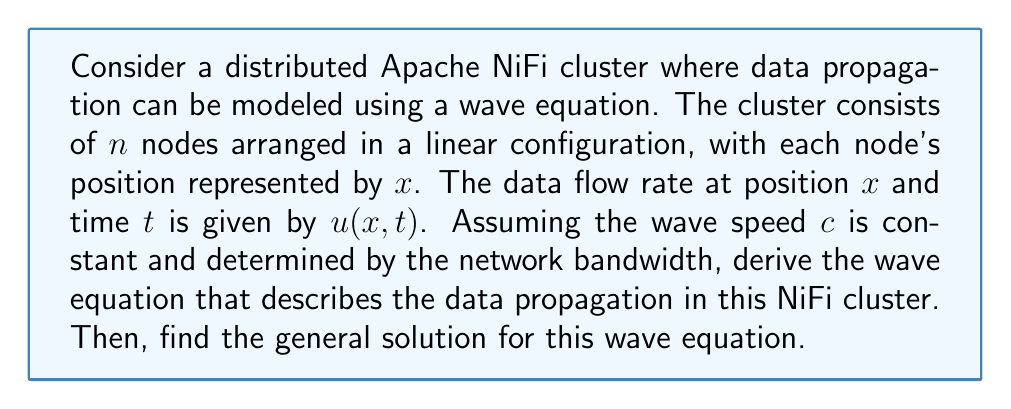Give your solution to this math problem. To solve this problem, we'll follow these steps:

1) First, we need to understand that the wave equation in one dimension is generally given by:

   $$\frac{\partial^2 u}{\partial t^2} = c^2 \frac{\partial^2 u}{\partial x^2}$$

   where $u$ is the quantity being propagated (in this case, the data flow rate), $t$ is time, $x$ is position, and $c$ is the wave speed.

2) In the context of a NiFi cluster, $c$ would represent the speed at which data propagates through the network, which is determined by the network bandwidth.

3) The wave equation for data propagation in the NiFi cluster would therefore be:

   $$\frac{\partial^2 u}{\partial t^2} = c^2 \frac{\partial^2 u}{\partial x^2}$$

   where $u(x,t)$ is the data flow rate at position $x$ and time $t$.

4) To find the general solution, we use the method of separation of variables. We assume a solution of the form:

   $$u(x,t) = X(x)T(t)$$

5) Substituting this into the wave equation:

   $$X(x)T''(t) = c^2X''(x)T(t)$$

6) Dividing both sides by $X(x)T(t)$:

   $$\frac{T''(t)}{T(t)} = c^2\frac{X''(x)}{X(x)} = -k^2$$

   where $k$ is a constant.

7) This gives us two ordinary differential equations:

   $$T''(t) + c^2k^2T(t) = 0$$
   $$X''(x) + k^2X(x) = 0$$

8) The general solutions to these equations are:

   $$T(t) = A\cos(ckt) + B\sin(ckt)$$
   $$X(x) = C\cos(kx) + D\sin(kx)$$

9) Therefore, the general solution to the wave equation is:

   $$u(x,t) = (C\cos(kx) + D\sin(kx))(A\cos(ckt) + B\sin(ckt))$$

   where $A$, $B$, $C$, and $D$ are constants determined by the initial and boundary conditions of the specific NiFi cluster configuration.
Answer: The wave equation for data propagation in the distributed NiFi cluster is:

$$\frac{\partial^2 u}{\partial t^2} = c^2 \frac{\partial^2 u}{\partial x^2}$$

The general solution is:

$$u(x,t) = (C\cos(kx) + D\sin(kx))(A\cos(ckt) + B\sin(ckt))$$

where $c$ is the wave speed determined by network bandwidth, and $A$, $B$, $C$, $D$, and $k$ are constants determined by initial and boundary conditions. 